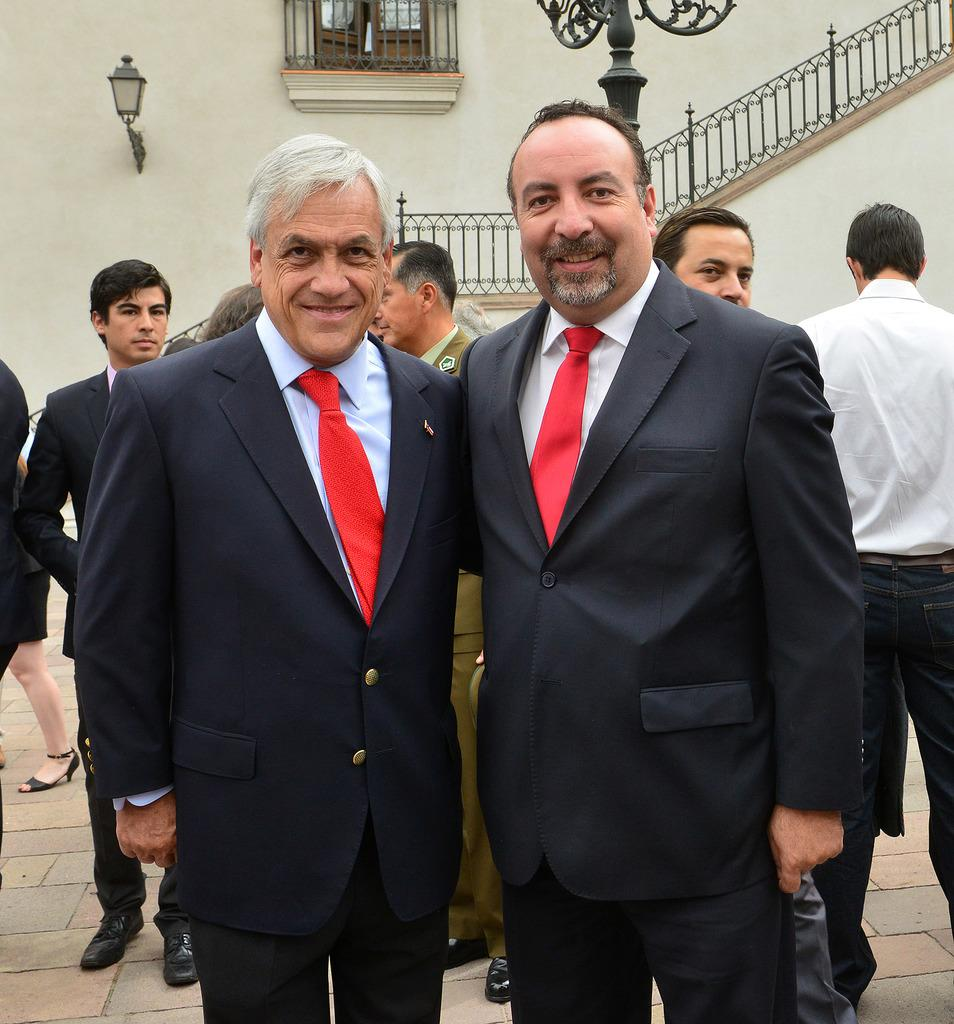How many people are smiling in the image? There are two persons standing and smiling in the image. What can be seen in the background of the image? There is a group of people standing, a window, a light, and a staircase of a building visible in the background of the image. What might be the purpose of the window in the background? The window in the background might provide natural light or a view of the surroundings. What architectural feature is visible in the background of the image? There is a staircase of a building visible in the background of the image. What type of lettuce is being used as a hat by one of the persons in the image? There is no lettuce present in the image, and no one is wearing a lettuce hat. 